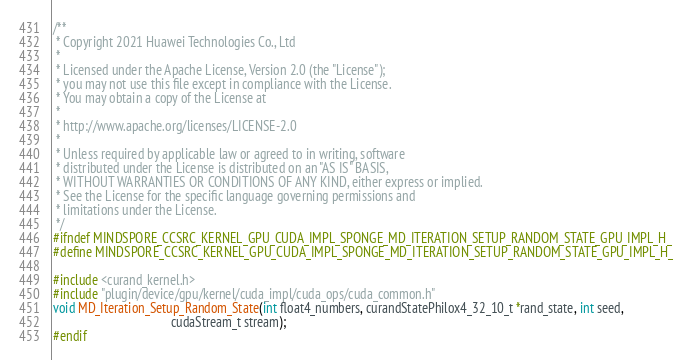Convert code to text. <code><loc_0><loc_0><loc_500><loc_500><_Cuda_>/**
 * Copyright 2021 Huawei Technologies Co., Ltd
 *
 * Licensed under the Apache License, Version 2.0 (the "License");
 * you may not use this file except in compliance with the License.
 * You may obtain a copy of the License at
 *
 * http://www.apache.org/licenses/LICENSE-2.0
 *
 * Unless required by applicable law or agreed to in writing, software
 * distributed under the License is distributed on an "AS IS" BASIS,
 * WITHOUT WARRANTIES OR CONDITIONS OF ANY KIND, either express or implied.
 * See the License for the specific language governing permissions and
 * limitations under the License.
 */
#ifndef MINDSPORE_CCSRC_KERNEL_GPU_CUDA_IMPL_SPONGE_MD_ITERATION_SETUP_RANDOM_STATE_GPU_IMPL_H_
#define MINDSPORE_CCSRC_KERNEL_GPU_CUDA_IMPL_SPONGE_MD_ITERATION_SETUP_RANDOM_STATE_GPU_IMPL_H_

#include <curand_kernel.h>
#include "plugin/device/gpu/kernel/cuda_impl/cuda_ops/cuda_common.h"
void MD_Iteration_Setup_Random_State(int float4_numbers, curandStatePhilox4_32_10_t *rand_state, int seed,
                                     cudaStream_t stream);
#endif
</code> 